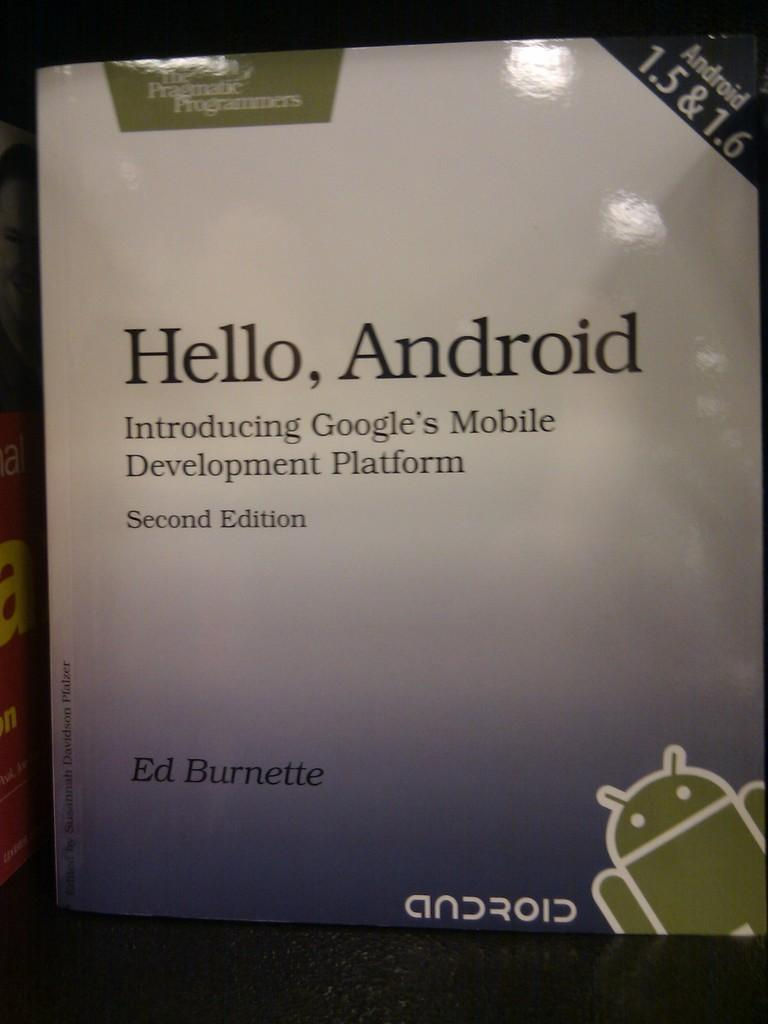<image>
Give a short and clear explanation of the subsequent image. A book by Ed Burnette called Hello, Android. 